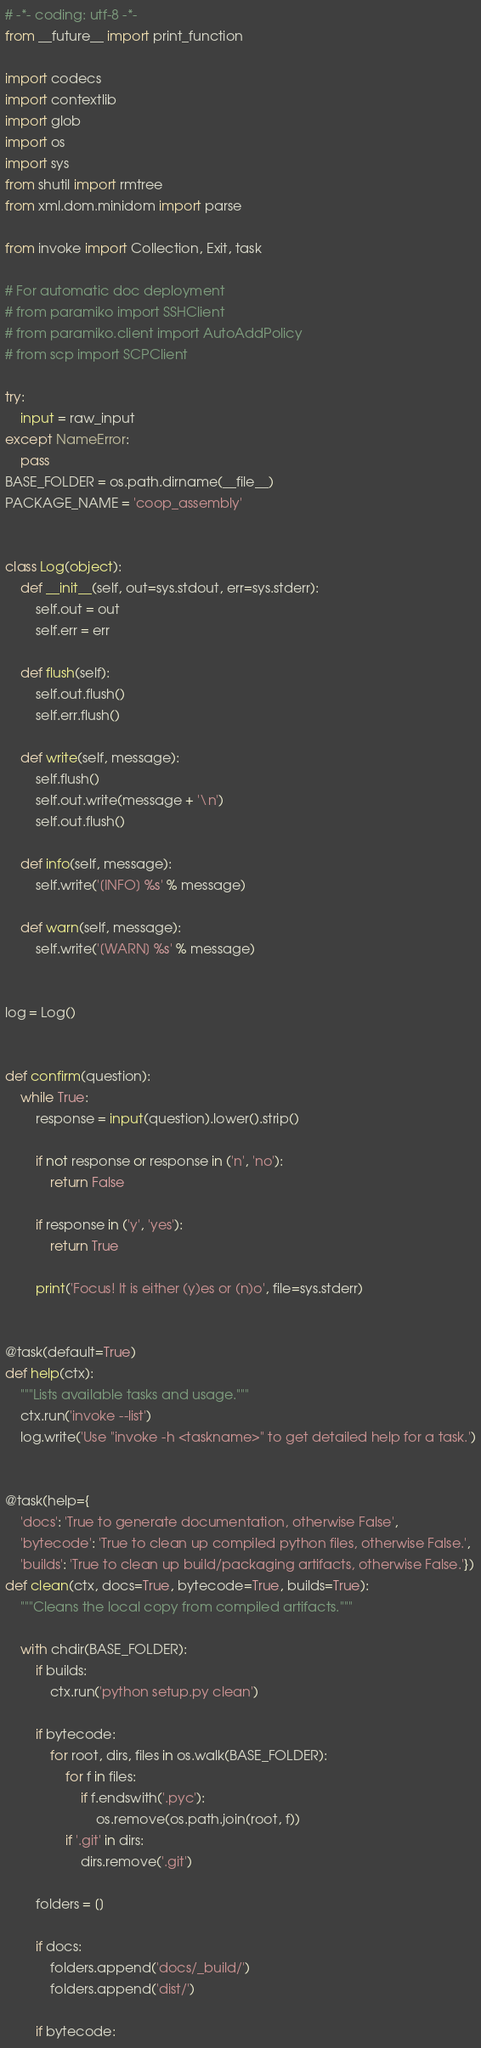Convert code to text. <code><loc_0><loc_0><loc_500><loc_500><_Python_># -*- coding: utf-8 -*-
from __future__ import print_function

import codecs
import contextlib
import glob
import os
import sys
from shutil import rmtree
from xml.dom.minidom import parse

from invoke import Collection, Exit, task

# For automatic doc deployment
# from paramiko import SSHClient
# from paramiko.client import AutoAddPolicy
# from scp import SCPClient

try:
    input = raw_input
except NameError:
    pass
BASE_FOLDER = os.path.dirname(__file__)
PACKAGE_NAME = 'coop_assembly'


class Log(object):
    def __init__(self, out=sys.stdout, err=sys.stderr):
        self.out = out
        self.err = err

    def flush(self):
        self.out.flush()
        self.err.flush()

    def write(self, message):
        self.flush()
        self.out.write(message + '\n')
        self.out.flush()

    def info(self, message):
        self.write('[INFO] %s' % message)

    def warn(self, message):
        self.write('[WARN] %s' % message)


log = Log()


def confirm(question):
    while True:
        response = input(question).lower().strip()

        if not response or response in ('n', 'no'):
            return False

        if response in ('y', 'yes'):
            return True

        print('Focus! It is either (y)es or (n)o', file=sys.stderr)


@task(default=True)
def help(ctx):
    """Lists available tasks and usage."""
    ctx.run('invoke --list')
    log.write('Use "invoke -h <taskname>" to get detailed help for a task.')


@task(help={
    'docs': 'True to generate documentation, otherwise False',
    'bytecode': 'True to clean up compiled python files, otherwise False.',
    'builds': 'True to clean up build/packaging artifacts, otherwise False.'})
def clean(ctx, docs=True, bytecode=True, builds=True):
    """Cleans the local copy from compiled artifacts."""

    with chdir(BASE_FOLDER):
        if builds:
            ctx.run('python setup.py clean')

        if bytecode:
            for root, dirs, files in os.walk(BASE_FOLDER):
                for f in files:
                    if f.endswith('.pyc'):
                        os.remove(os.path.join(root, f))
                if '.git' in dirs:
                    dirs.remove('.git')

        folders = []

        if docs:
            folders.append('docs/_build/')
            folders.append('dist/')

        if bytecode:</code> 